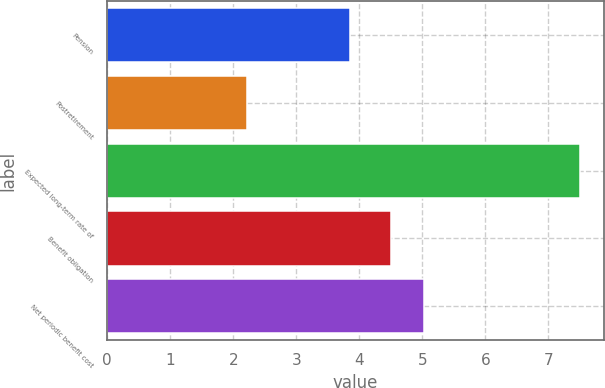Convert chart. <chart><loc_0><loc_0><loc_500><loc_500><bar_chart><fcel>Pension<fcel>Postretirement<fcel>Expected long-term rate of<fcel>Benefit obligation<fcel>Net periodic benefit cost<nl><fcel>3.85<fcel>2.21<fcel>7.5<fcel>4.5<fcel>5.03<nl></chart> 